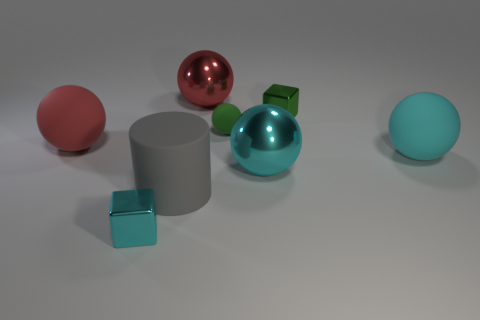Add 1 big cyan things. How many objects exist? 9 Subtract all balls. How many objects are left? 3 Subtract 0 yellow cubes. How many objects are left? 8 Subtract all large gray shiny cubes. Subtract all large metal objects. How many objects are left? 6 Add 5 cyan rubber objects. How many cyan rubber objects are left? 6 Add 1 big matte objects. How many big matte objects exist? 4 